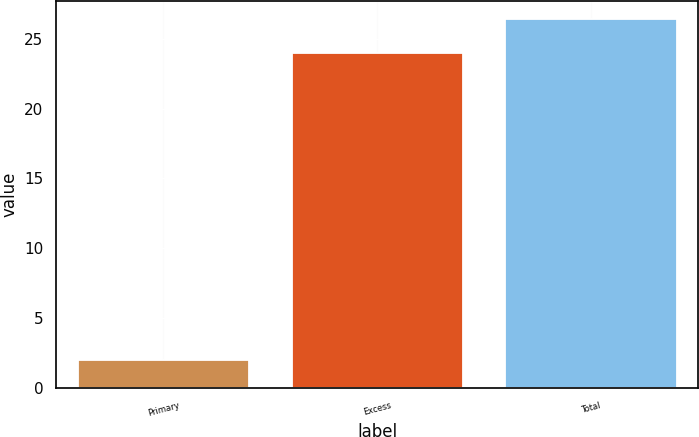Convert chart to OTSL. <chart><loc_0><loc_0><loc_500><loc_500><bar_chart><fcel>Primary<fcel>Excess<fcel>Total<nl><fcel>2<fcel>24<fcel>26.4<nl></chart> 